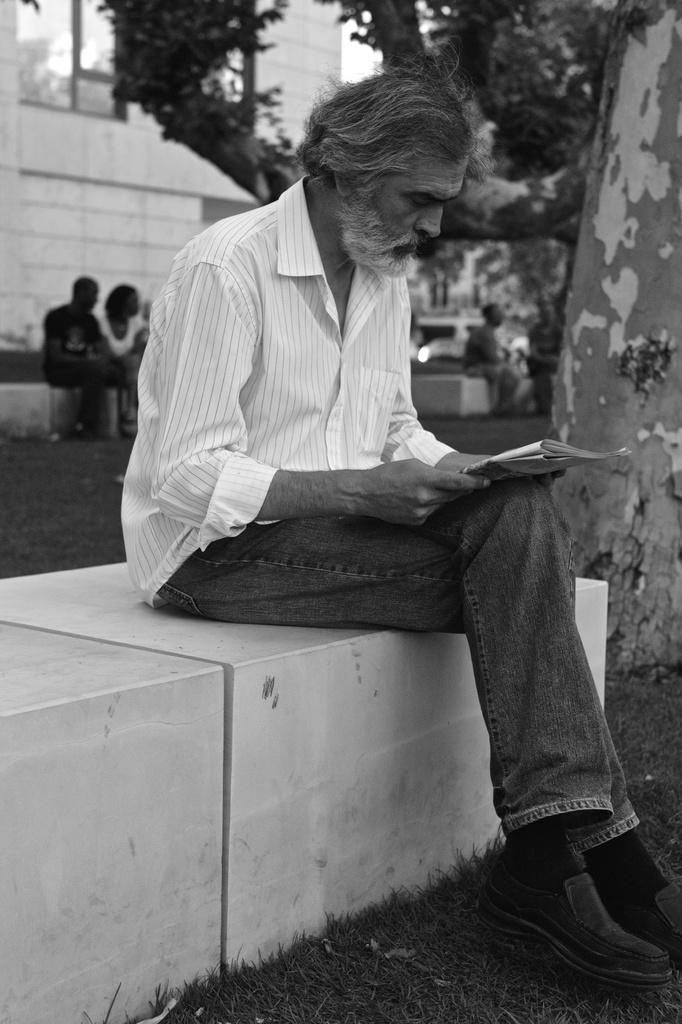What is the person in the image doing? The person is holding a paper and sitting. What can be seen in the background of the image? There is a building and a tree in the image. What type of argument is the person having with the tree in the image? There is no argument present in the image, and the person is not interacting with the tree. 